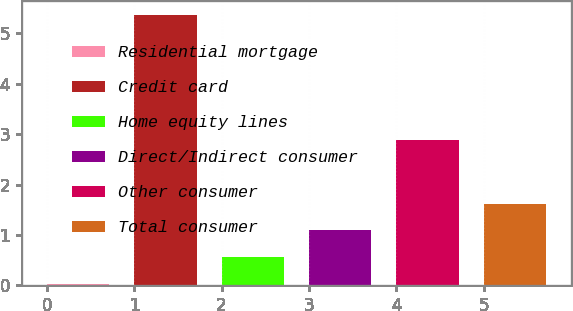<chart> <loc_0><loc_0><loc_500><loc_500><bar_chart><fcel>Residential mortgage<fcel>Credit card<fcel>Home equity lines<fcel>Direct/Indirect consumer<fcel>Other consumer<fcel>Total consumer<nl><fcel>0.03<fcel>5.37<fcel>0.56<fcel>1.09<fcel>2.89<fcel>1.62<nl></chart> 